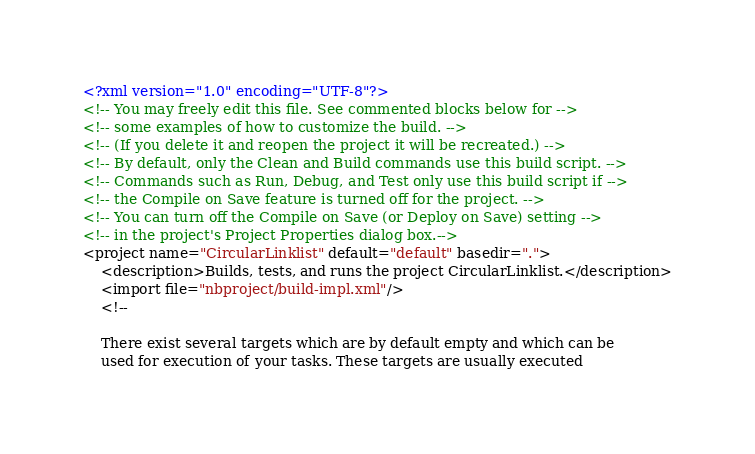<code> <loc_0><loc_0><loc_500><loc_500><_XML_><?xml version="1.0" encoding="UTF-8"?>
<!-- You may freely edit this file. See commented blocks below for -->
<!-- some examples of how to customize the build. -->
<!-- (If you delete it and reopen the project it will be recreated.) -->
<!-- By default, only the Clean and Build commands use this build script. -->
<!-- Commands such as Run, Debug, and Test only use this build script if -->
<!-- the Compile on Save feature is turned off for the project. -->
<!-- You can turn off the Compile on Save (or Deploy on Save) setting -->
<!-- in the project's Project Properties dialog box.-->
<project name="CircularLinklist" default="default" basedir=".">
    <description>Builds, tests, and runs the project CircularLinklist.</description>
    <import file="nbproject/build-impl.xml"/>
    <!--

    There exist several targets which are by default empty and which can be 
    used for execution of your tasks. These targets are usually executed </code> 